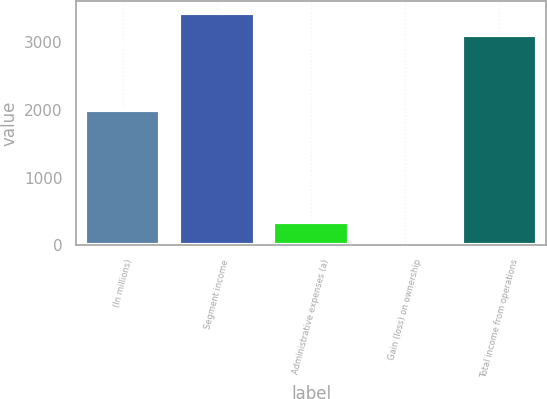Convert chart. <chart><loc_0><loc_0><loc_500><loc_500><bar_chart><fcel>(In millions)<fcel>Segment income<fcel>Administrative expenses (a)<fcel>Gain (loss) on ownership<fcel>Total income from operations<nl><fcel>2001<fcel>3440.1<fcel>338.1<fcel>6<fcel>3108<nl></chart> 